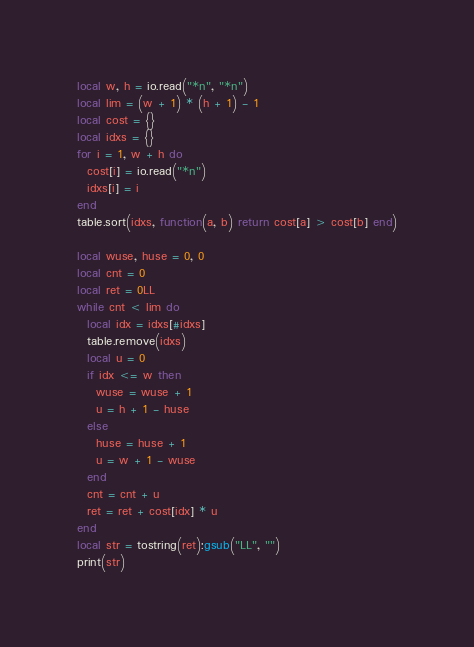<code> <loc_0><loc_0><loc_500><loc_500><_Lua_>local w, h = io.read("*n", "*n")
local lim = (w + 1) * (h + 1) - 1
local cost = {}
local idxs = {}
for i = 1, w + h do
  cost[i] = io.read("*n")
  idxs[i] = i
end
table.sort(idxs, function(a, b) return cost[a] > cost[b] end)

local wuse, huse = 0, 0
local cnt = 0
local ret = 0LL
while cnt < lim do
  local idx = idxs[#idxs]
  table.remove(idxs)
  local u = 0
  if idx <= w then
    wuse = wuse + 1
    u = h + 1 - huse
  else
    huse = huse + 1
    u = w + 1 - wuse
  end
  cnt = cnt + u
  ret = ret + cost[idx] * u
end
local str = tostring(ret):gsub("LL", "")
print(str)
</code> 